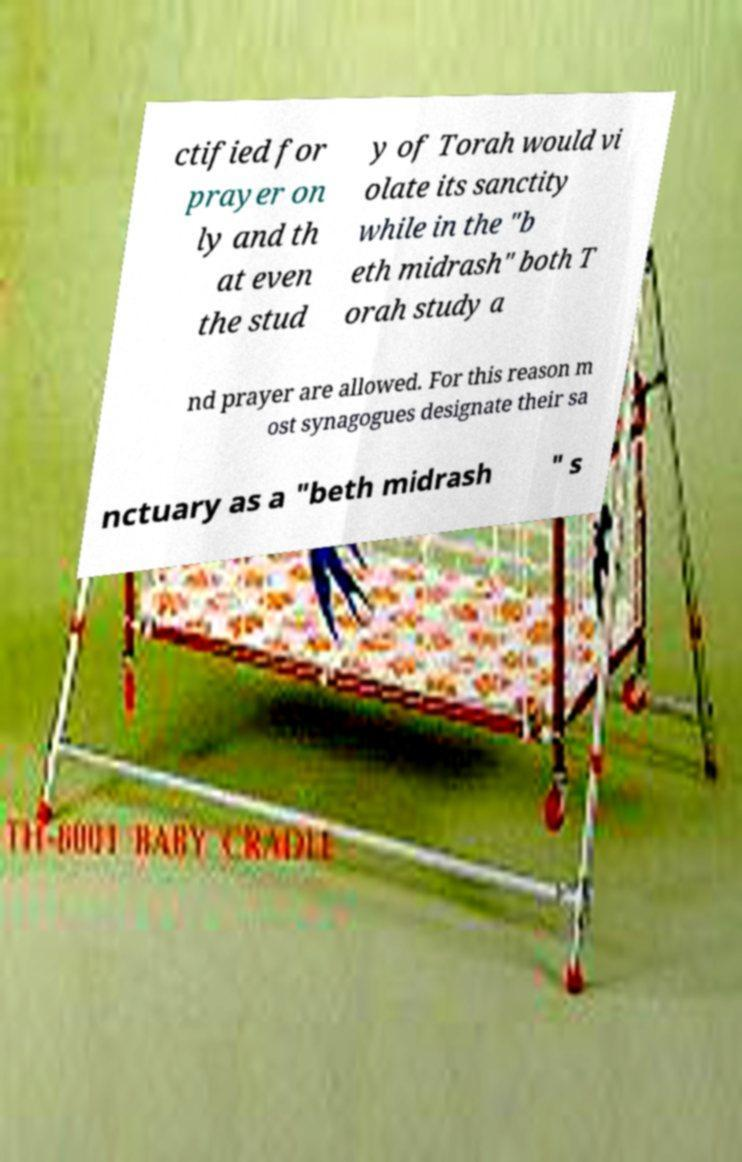For documentation purposes, I need the text within this image transcribed. Could you provide that? ctified for prayer on ly and th at even the stud y of Torah would vi olate its sanctity while in the "b eth midrash" both T orah study a nd prayer are allowed. For this reason m ost synagogues designate their sa nctuary as a "beth midrash " s 